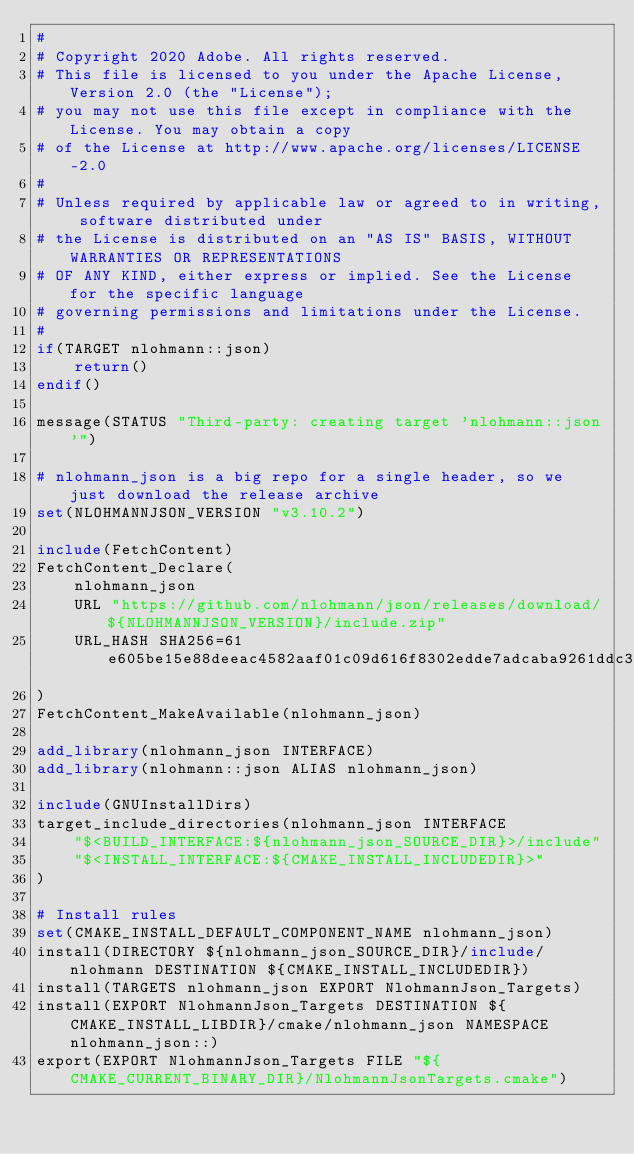<code> <loc_0><loc_0><loc_500><loc_500><_CMake_>#
# Copyright 2020 Adobe. All rights reserved.
# This file is licensed to you under the Apache License, Version 2.0 (the "License");
# you may not use this file except in compliance with the License. You may obtain a copy
# of the License at http://www.apache.org/licenses/LICENSE-2.0
#
# Unless required by applicable law or agreed to in writing, software distributed under
# the License is distributed on an "AS IS" BASIS, WITHOUT WARRANTIES OR REPRESENTATIONS
# OF ANY KIND, either express or implied. See the License for the specific language
# governing permissions and limitations under the License.
#
if(TARGET nlohmann::json)
    return()
endif()

message(STATUS "Third-party: creating target 'nlohmann::json'")

# nlohmann_json is a big repo for a single header, so we just download the release archive
set(NLOHMANNJSON_VERSION "v3.10.2")

include(FetchContent)
FetchContent_Declare(
    nlohmann_json
    URL "https://github.com/nlohmann/json/releases/download/${NLOHMANNJSON_VERSION}/include.zip"
    URL_HASH SHA256=61e605be15e88deeac4582aaf01c09d616f8302edde7adcaba9261ddc3b4ceca
)
FetchContent_MakeAvailable(nlohmann_json)

add_library(nlohmann_json INTERFACE)
add_library(nlohmann::json ALIAS nlohmann_json)

include(GNUInstallDirs)
target_include_directories(nlohmann_json INTERFACE
    "$<BUILD_INTERFACE:${nlohmann_json_SOURCE_DIR}>/include"
    "$<INSTALL_INTERFACE:${CMAKE_INSTALL_INCLUDEDIR}>"
)

# Install rules
set(CMAKE_INSTALL_DEFAULT_COMPONENT_NAME nlohmann_json)
install(DIRECTORY ${nlohmann_json_SOURCE_DIR}/include/nlohmann DESTINATION ${CMAKE_INSTALL_INCLUDEDIR})
install(TARGETS nlohmann_json EXPORT NlohmannJson_Targets)
install(EXPORT NlohmannJson_Targets DESTINATION ${CMAKE_INSTALL_LIBDIR}/cmake/nlohmann_json NAMESPACE nlohmann_json::)
export(EXPORT NlohmannJson_Targets FILE "${CMAKE_CURRENT_BINARY_DIR}/NlohmannJsonTargets.cmake")
</code> 